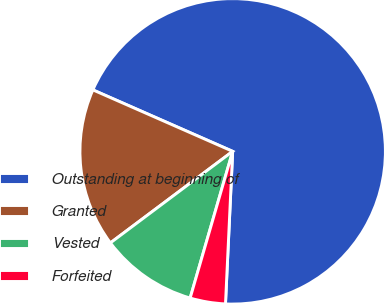<chart> <loc_0><loc_0><loc_500><loc_500><pie_chart><fcel>Outstanding at beginning of<fcel>Granted<fcel>Vested<fcel>Forfeited<nl><fcel>69.15%<fcel>16.82%<fcel>10.28%<fcel>3.74%<nl></chart> 